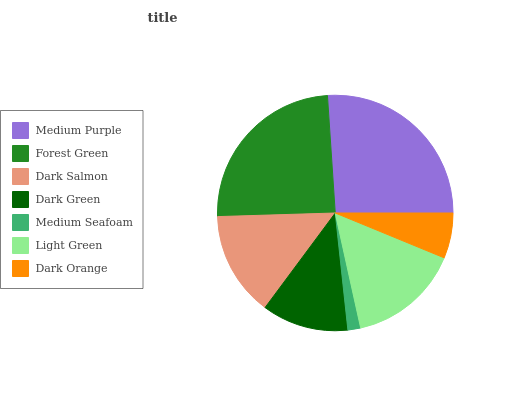Is Medium Seafoam the minimum?
Answer yes or no. Yes. Is Medium Purple the maximum?
Answer yes or no. Yes. Is Forest Green the minimum?
Answer yes or no. No. Is Forest Green the maximum?
Answer yes or no. No. Is Medium Purple greater than Forest Green?
Answer yes or no. Yes. Is Forest Green less than Medium Purple?
Answer yes or no. Yes. Is Forest Green greater than Medium Purple?
Answer yes or no. No. Is Medium Purple less than Forest Green?
Answer yes or no. No. Is Dark Salmon the high median?
Answer yes or no. Yes. Is Dark Salmon the low median?
Answer yes or no. Yes. Is Medium Seafoam the high median?
Answer yes or no. No. Is Dark Orange the low median?
Answer yes or no. No. 